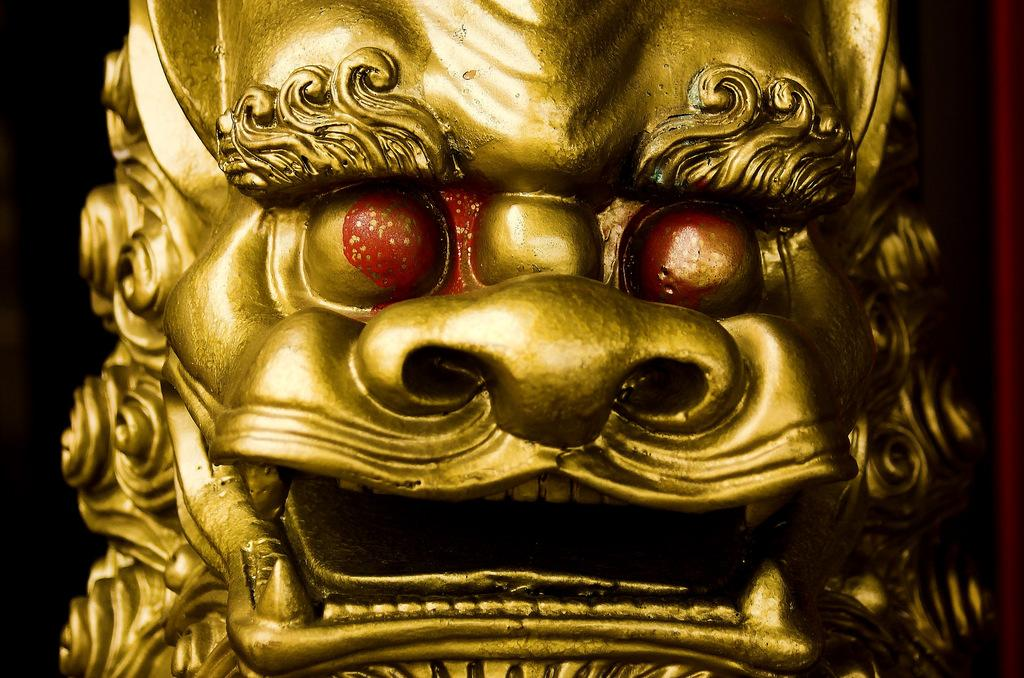What is the main subject of the image? The main subject of the image is a golden color sculpture. Can you describe any specific features of the sculpture? Yes, the sculpture has two red color spots in its eyes. What type of ball is being used in the battle scene depicted in the image? There is no ball or battle scene present in the image; it features of the sculpture are the focus. What is the material of the copper sculpture in the image? The sculpture is described as golden color, not copper, so we cannot determine its material from the image. 